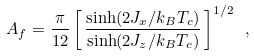Convert formula to latex. <formula><loc_0><loc_0><loc_500><loc_500>A _ { f } = \frac { \pi } { 1 2 } \left [ \, \frac { \sinh ( 2 J _ { x } / k _ { B } T _ { c } ) } { \sinh ( 2 J _ { z } / k _ { B } T _ { c } ) } \, \right ] ^ { 1 / 2 } \ ,</formula> 